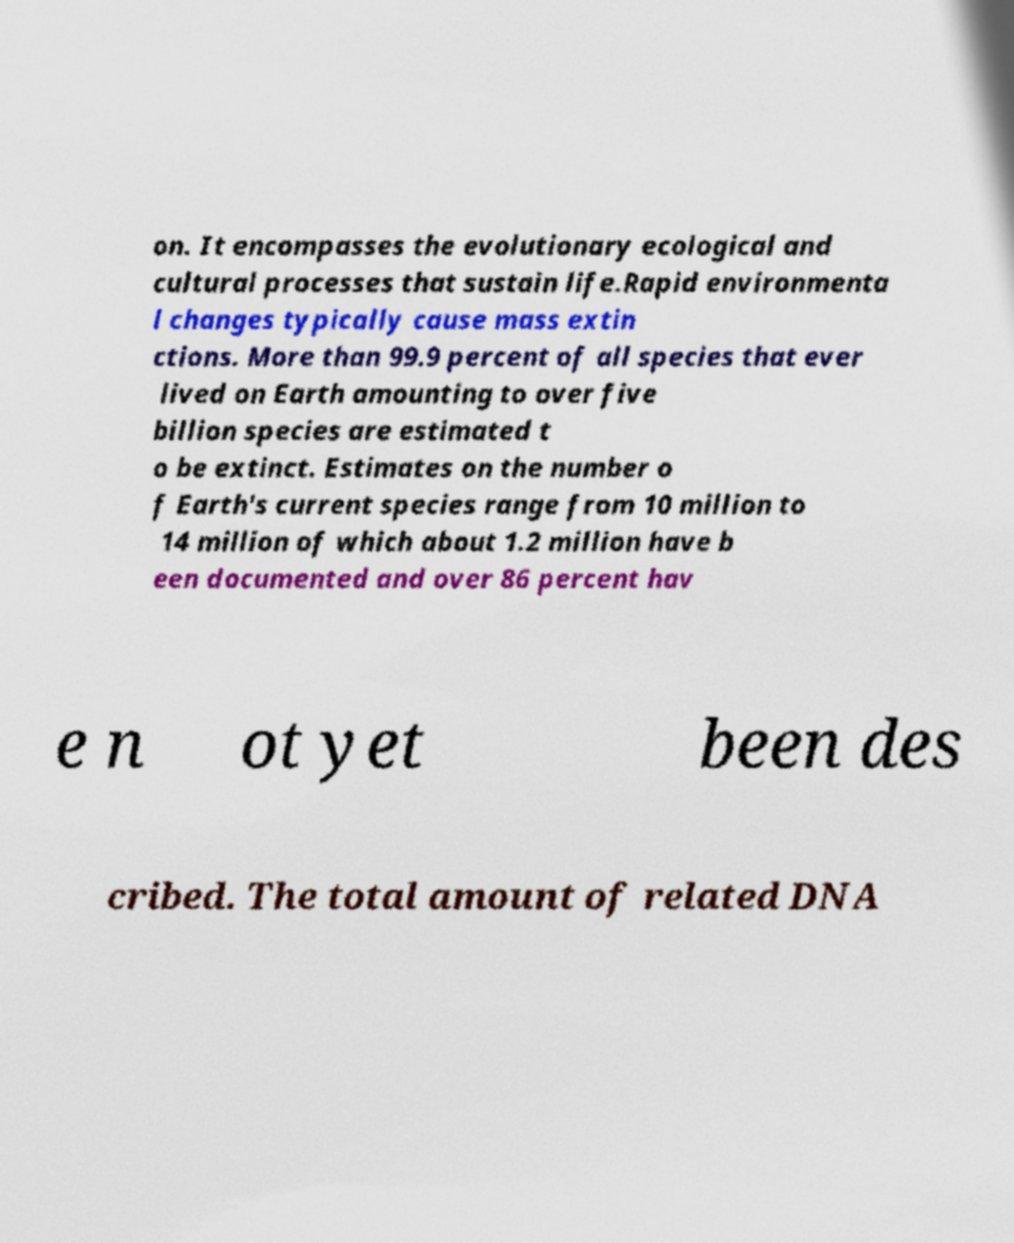For documentation purposes, I need the text within this image transcribed. Could you provide that? on. It encompasses the evolutionary ecological and cultural processes that sustain life.Rapid environmenta l changes typically cause mass extin ctions. More than 99.9 percent of all species that ever lived on Earth amounting to over five billion species are estimated t o be extinct. Estimates on the number o f Earth's current species range from 10 million to 14 million of which about 1.2 million have b een documented and over 86 percent hav e n ot yet been des cribed. The total amount of related DNA 